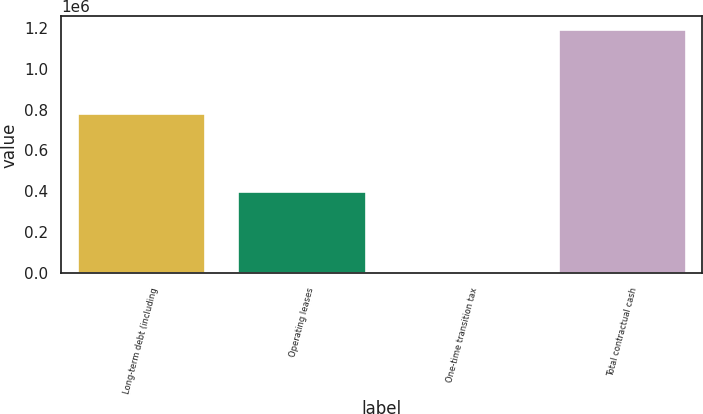Convert chart to OTSL. <chart><loc_0><loc_0><loc_500><loc_500><bar_chart><fcel>Long-term debt (including<fcel>Operating leases<fcel>One-time transition tax<fcel>Total contractual cash<nl><fcel>781969<fcel>401809<fcel>4053<fcel>1.19511e+06<nl></chart> 